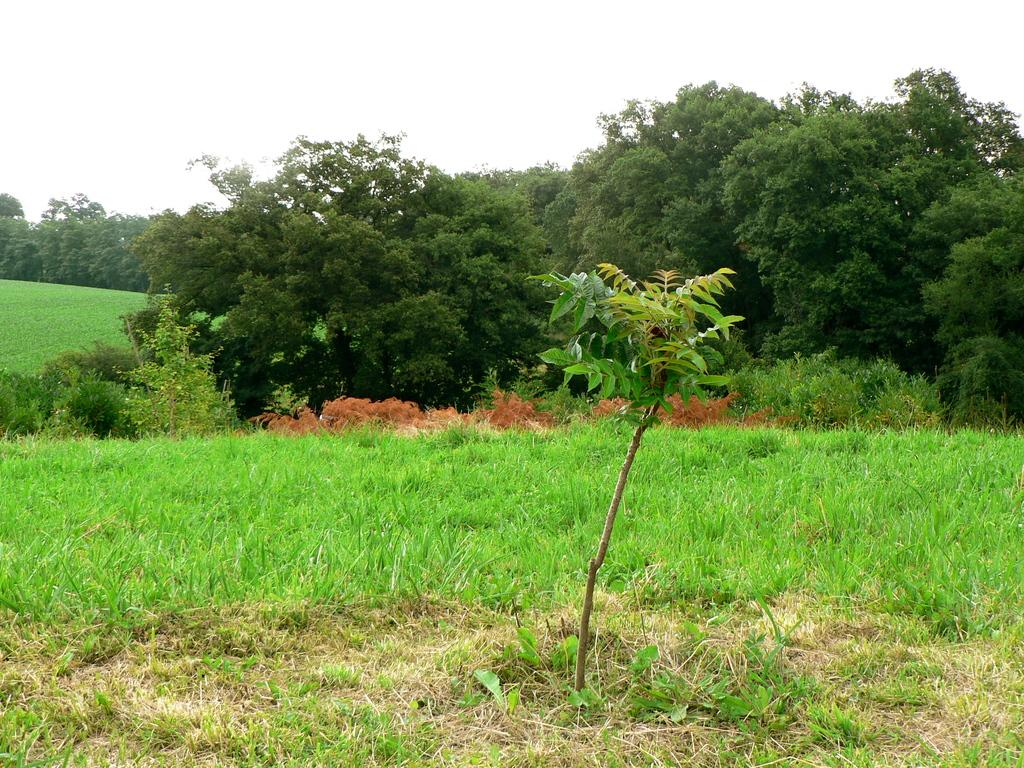What can be seen in the sky in the image? The sky is visible in the image. What type of vegetation is present in the image? There are trees and plants in the image. What type of ground cover is visible in the image? There is grass in the image. What type of blade is being used to rub the trees in the image? There is no blade or rubbing action present in the image; it features the sky, trees, plants, and grass. 